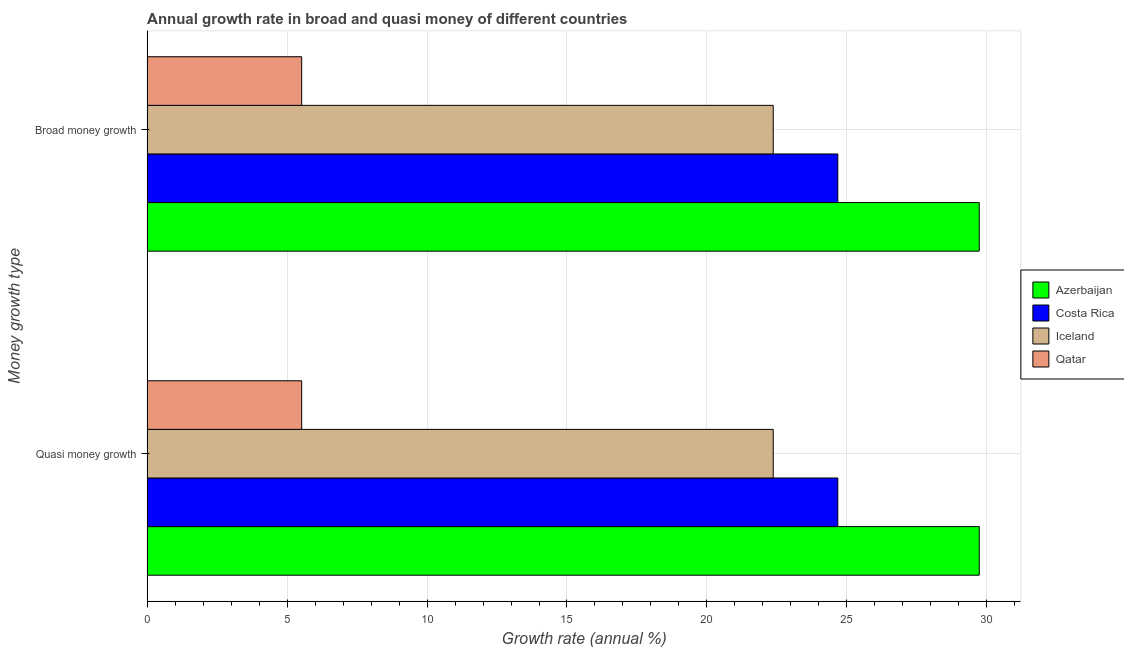How many groups of bars are there?
Your answer should be compact. 2. How many bars are there on the 1st tick from the top?
Make the answer very short. 4. How many bars are there on the 2nd tick from the bottom?
Offer a very short reply. 4. What is the label of the 1st group of bars from the top?
Offer a very short reply. Broad money growth. What is the annual growth rate in quasi money in Qatar?
Your answer should be compact. 5.52. Across all countries, what is the maximum annual growth rate in broad money?
Offer a very short reply. 29.73. Across all countries, what is the minimum annual growth rate in quasi money?
Keep it short and to the point. 5.52. In which country was the annual growth rate in broad money maximum?
Provide a succinct answer. Azerbaijan. In which country was the annual growth rate in broad money minimum?
Offer a very short reply. Qatar. What is the total annual growth rate in quasi money in the graph?
Offer a terse response. 82.3. What is the difference between the annual growth rate in quasi money in Iceland and that in Costa Rica?
Offer a very short reply. -2.31. What is the difference between the annual growth rate in broad money in Azerbaijan and the annual growth rate in quasi money in Costa Rica?
Keep it short and to the point. 5.05. What is the average annual growth rate in broad money per country?
Offer a very short reply. 20.57. In how many countries, is the annual growth rate in broad money greater than 25 %?
Ensure brevity in your answer.  1. What is the ratio of the annual growth rate in broad money in Iceland to that in Azerbaijan?
Ensure brevity in your answer.  0.75. In how many countries, is the annual growth rate in broad money greater than the average annual growth rate in broad money taken over all countries?
Offer a very short reply. 3. What does the 1st bar from the top in Quasi money growth represents?
Keep it short and to the point. Qatar. What does the 4th bar from the bottom in Quasi money growth represents?
Provide a succinct answer. Qatar. How many bars are there?
Provide a succinct answer. 8. Are all the bars in the graph horizontal?
Offer a terse response. Yes. What is the difference between two consecutive major ticks on the X-axis?
Offer a terse response. 5. Does the graph contain any zero values?
Your response must be concise. No. How are the legend labels stacked?
Your answer should be very brief. Vertical. What is the title of the graph?
Offer a terse response. Annual growth rate in broad and quasi money of different countries. What is the label or title of the X-axis?
Keep it short and to the point. Growth rate (annual %). What is the label or title of the Y-axis?
Your response must be concise. Money growth type. What is the Growth rate (annual %) in Azerbaijan in Quasi money growth?
Your answer should be compact. 29.73. What is the Growth rate (annual %) in Costa Rica in Quasi money growth?
Provide a succinct answer. 24.68. What is the Growth rate (annual %) of Iceland in Quasi money growth?
Provide a succinct answer. 22.37. What is the Growth rate (annual %) in Qatar in Quasi money growth?
Your answer should be compact. 5.52. What is the Growth rate (annual %) of Azerbaijan in Broad money growth?
Ensure brevity in your answer.  29.73. What is the Growth rate (annual %) of Costa Rica in Broad money growth?
Give a very brief answer. 24.68. What is the Growth rate (annual %) in Iceland in Broad money growth?
Offer a terse response. 22.37. What is the Growth rate (annual %) in Qatar in Broad money growth?
Offer a very short reply. 5.52. Across all Money growth type, what is the maximum Growth rate (annual %) in Azerbaijan?
Offer a terse response. 29.73. Across all Money growth type, what is the maximum Growth rate (annual %) in Costa Rica?
Your answer should be very brief. 24.68. Across all Money growth type, what is the maximum Growth rate (annual %) in Iceland?
Ensure brevity in your answer.  22.37. Across all Money growth type, what is the maximum Growth rate (annual %) of Qatar?
Your response must be concise. 5.52. Across all Money growth type, what is the minimum Growth rate (annual %) in Azerbaijan?
Offer a terse response. 29.73. Across all Money growth type, what is the minimum Growth rate (annual %) of Costa Rica?
Ensure brevity in your answer.  24.68. Across all Money growth type, what is the minimum Growth rate (annual %) of Iceland?
Provide a short and direct response. 22.37. Across all Money growth type, what is the minimum Growth rate (annual %) of Qatar?
Your answer should be compact. 5.52. What is the total Growth rate (annual %) of Azerbaijan in the graph?
Your answer should be compact. 59.46. What is the total Growth rate (annual %) of Costa Rica in the graph?
Ensure brevity in your answer.  49.35. What is the total Growth rate (annual %) of Iceland in the graph?
Your answer should be very brief. 44.74. What is the total Growth rate (annual %) in Qatar in the graph?
Your answer should be compact. 11.04. What is the difference between the Growth rate (annual %) in Azerbaijan in Quasi money growth and that in Broad money growth?
Provide a short and direct response. 0. What is the difference between the Growth rate (annual %) in Iceland in Quasi money growth and that in Broad money growth?
Your response must be concise. 0. What is the difference between the Growth rate (annual %) in Qatar in Quasi money growth and that in Broad money growth?
Ensure brevity in your answer.  0. What is the difference between the Growth rate (annual %) in Azerbaijan in Quasi money growth and the Growth rate (annual %) in Costa Rica in Broad money growth?
Your response must be concise. 5.05. What is the difference between the Growth rate (annual %) of Azerbaijan in Quasi money growth and the Growth rate (annual %) of Iceland in Broad money growth?
Your answer should be compact. 7.36. What is the difference between the Growth rate (annual %) in Azerbaijan in Quasi money growth and the Growth rate (annual %) in Qatar in Broad money growth?
Your response must be concise. 24.21. What is the difference between the Growth rate (annual %) of Costa Rica in Quasi money growth and the Growth rate (annual %) of Iceland in Broad money growth?
Make the answer very short. 2.31. What is the difference between the Growth rate (annual %) of Costa Rica in Quasi money growth and the Growth rate (annual %) of Qatar in Broad money growth?
Keep it short and to the point. 19.16. What is the difference between the Growth rate (annual %) of Iceland in Quasi money growth and the Growth rate (annual %) of Qatar in Broad money growth?
Ensure brevity in your answer.  16.85. What is the average Growth rate (annual %) in Azerbaijan per Money growth type?
Offer a terse response. 29.73. What is the average Growth rate (annual %) of Costa Rica per Money growth type?
Give a very brief answer. 24.68. What is the average Growth rate (annual %) of Iceland per Money growth type?
Offer a terse response. 22.37. What is the average Growth rate (annual %) of Qatar per Money growth type?
Offer a very short reply. 5.52. What is the difference between the Growth rate (annual %) of Azerbaijan and Growth rate (annual %) of Costa Rica in Quasi money growth?
Provide a short and direct response. 5.05. What is the difference between the Growth rate (annual %) in Azerbaijan and Growth rate (annual %) in Iceland in Quasi money growth?
Make the answer very short. 7.36. What is the difference between the Growth rate (annual %) of Azerbaijan and Growth rate (annual %) of Qatar in Quasi money growth?
Offer a very short reply. 24.21. What is the difference between the Growth rate (annual %) in Costa Rica and Growth rate (annual %) in Iceland in Quasi money growth?
Offer a terse response. 2.31. What is the difference between the Growth rate (annual %) in Costa Rica and Growth rate (annual %) in Qatar in Quasi money growth?
Your answer should be very brief. 19.16. What is the difference between the Growth rate (annual %) in Iceland and Growth rate (annual %) in Qatar in Quasi money growth?
Give a very brief answer. 16.85. What is the difference between the Growth rate (annual %) in Azerbaijan and Growth rate (annual %) in Costa Rica in Broad money growth?
Offer a terse response. 5.05. What is the difference between the Growth rate (annual %) of Azerbaijan and Growth rate (annual %) of Iceland in Broad money growth?
Keep it short and to the point. 7.36. What is the difference between the Growth rate (annual %) of Azerbaijan and Growth rate (annual %) of Qatar in Broad money growth?
Your answer should be very brief. 24.21. What is the difference between the Growth rate (annual %) in Costa Rica and Growth rate (annual %) in Iceland in Broad money growth?
Your answer should be very brief. 2.31. What is the difference between the Growth rate (annual %) in Costa Rica and Growth rate (annual %) in Qatar in Broad money growth?
Keep it short and to the point. 19.16. What is the difference between the Growth rate (annual %) of Iceland and Growth rate (annual %) of Qatar in Broad money growth?
Provide a succinct answer. 16.85. What is the ratio of the Growth rate (annual %) of Costa Rica in Quasi money growth to that in Broad money growth?
Your answer should be compact. 1. What is the ratio of the Growth rate (annual %) of Iceland in Quasi money growth to that in Broad money growth?
Make the answer very short. 1. What is the difference between the highest and the second highest Growth rate (annual %) in Costa Rica?
Give a very brief answer. 0. What is the difference between the highest and the second highest Growth rate (annual %) of Iceland?
Give a very brief answer. 0. What is the difference between the highest and the lowest Growth rate (annual %) in Azerbaijan?
Offer a very short reply. 0. What is the difference between the highest and the lowest Growth rate (annual %) of Costa Rica?
Ensure brevity in your answer.  0. 